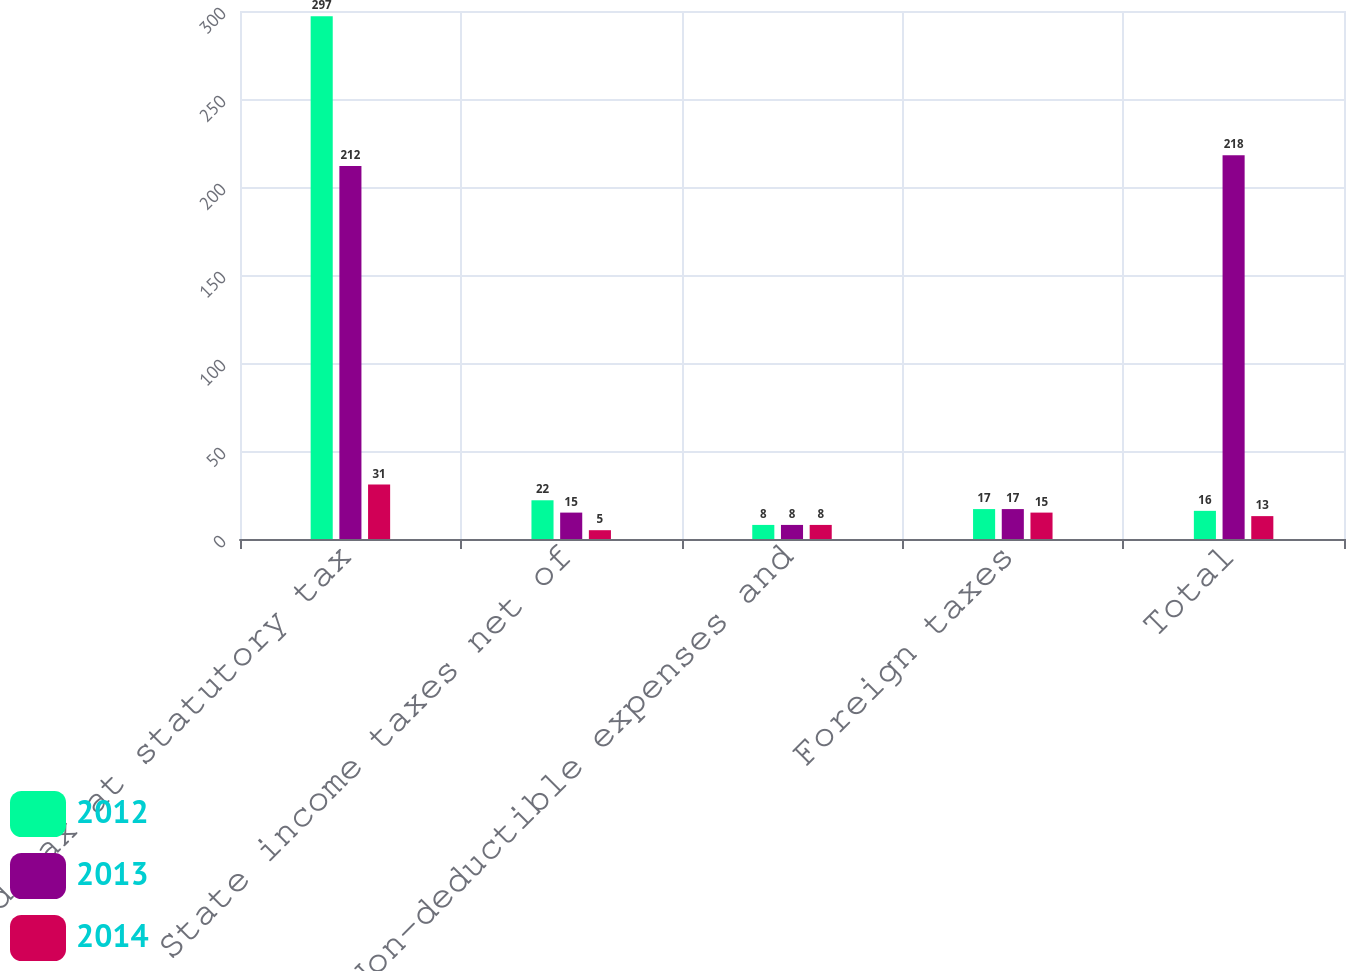Convert chart to OTSL. <chart><loc_0><loc_0><loc_500><loc_500><stacked_bar_chart><ecel><fcel>Computed tax at statutory tax<fcel>State income taxes net of<fcel>Non-deductible expenses and<fcel>Foreign taxes<fcel>Total<nl><fcel>2012<fcel>297<fcel>22<fcel>8<fcel>17<fcel>16<nl><fcel>2013<fcel>212<fcel>15<fcel>8<fcel>17<fcel>218<nl><fcel>2014<fcel>31<fcel>5<fcel>8<fcel>15<fcel>13<nl></chart> 